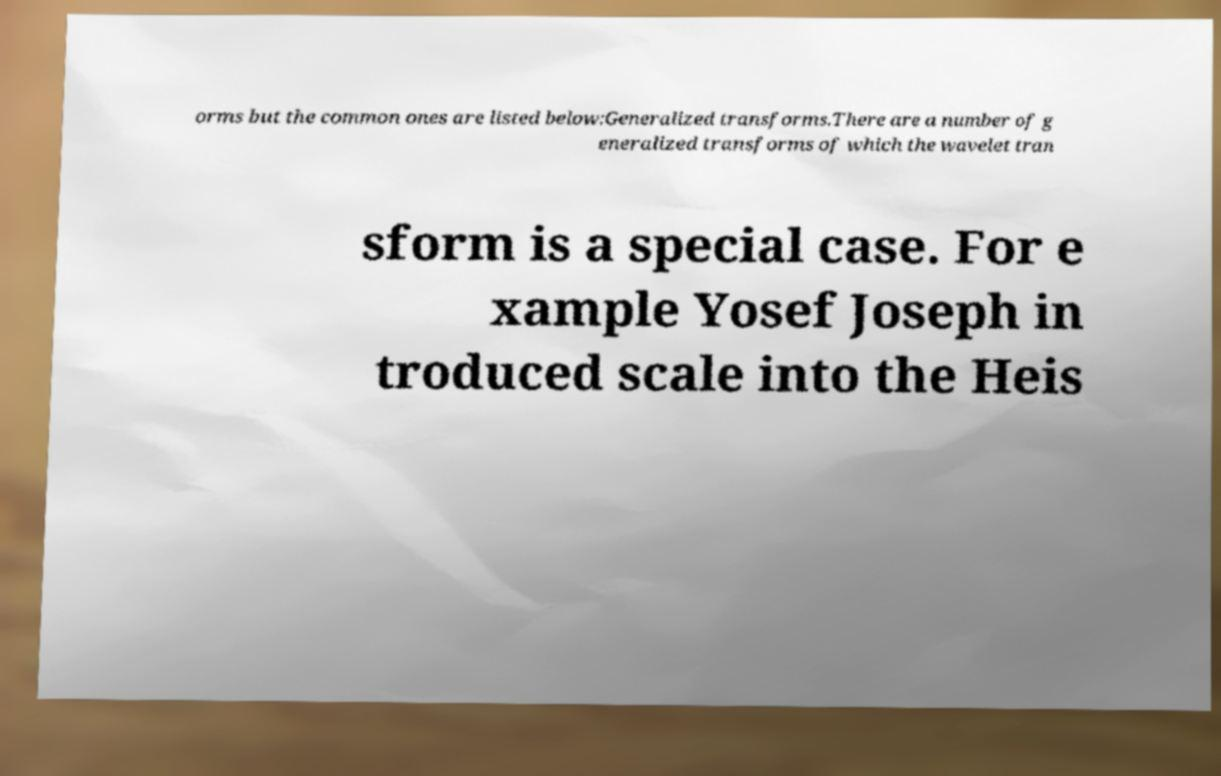Could you assist in decoding the text presented in this image and type it out clearly? orms but the common ones are listed below:Generalized transforms.There are a number of g eneralized transforms of which the wavelet tran sform is a special case. For e xample Yosef Joseph in troduced scale into the Heis 